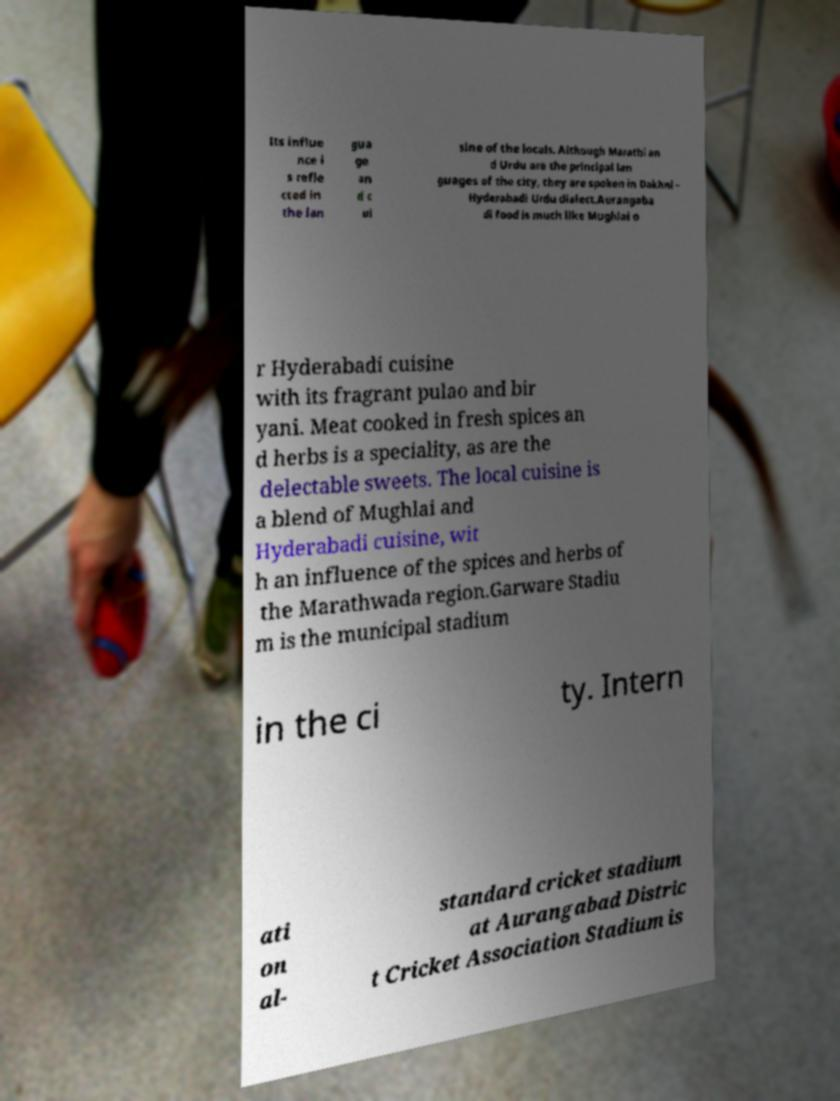There's text embedded in this image that I need extracted. Can you transcribe it verbatim? Its influe nce i s refle cted in the lan gua ge an d c ui sine of the locals. Although Marathi an d Urdu are the principal lan guages of the city, they are spoken in Dakhni – Hyderabadi Urdu dialect.Aurangaba di food is much like Mughlai o r Hyderabadi cuisine with its fragrant pulao and bir yani. Meat cooked in fresh spices an d herbs is a speciality, as are the delectable sweets. The local cuisine is a blend of Mughlai and Hyderabadi cuisine, wit h an influence of the spices and herbs of the Marathwada region.Garware Stadiu m is the municipal stadium in the ci ty. Intern ati on al- standard cricket stadium at Aurangabad Distric t Cricket Association Stadium is 